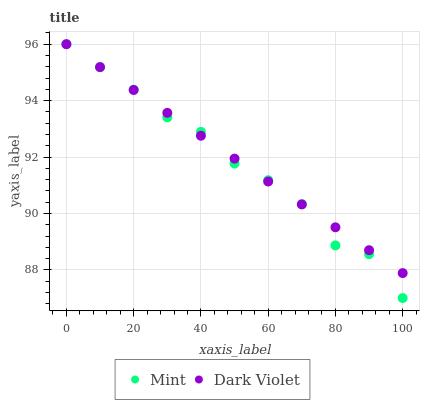Does Mint have the minimum area under the curve?
Answer yes or no. Yes. Does Dark Violet have the maximum area under the curve?
Answer yes or no. Yes. Does Dark Violet have the minimum area under the curve?
Answer yes or no. No. Is Dark Violet the smoothest?
Answer yes or no. Yes. Is Mint the roughest?
Answer yes or no. Yes. Is Dark Violet the roughest?
Answer yes or no. No. Does Mint have the lowest value?
Answer yes or no. Yes. Does Dark Violet have the lowest value?
Answer yes or no. No. Does Dark Violet have the highest value?
Answer yes or no. Yes. Does Mint intersect Dark Violet?
Answer yes or no. Yes. Is Mint less than Dark Violet?
Answer yes or no. No. Is Mint greater than Dark Violet?
Answer yes or no. No. 